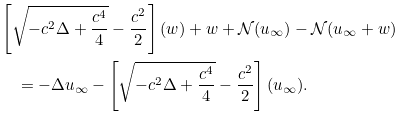<formula> <loc_0><loc_0><loc_500><loc_500>& \left [ \sqrt { - c ^ { 2 } \Delta + \frac { c ^ { 4 } } { 4 } } - \frac { c ^ { 2 } } { 2 } \right ] ( w ) + w + \mathcal { N } ( u _ { \infty } ) - \mathcal { N } ( u _ { \infty } + w ) \\ & \quad = - \Delta u _ { \infty } - \left [ \sqrt { - c ^ { 2 } \Delta + \frac { c ^ { 4 } } { 4 } } - \frac { c ^ { 2 } } { 2 } \right ] ( u _ { \infty } ) .</formula> 